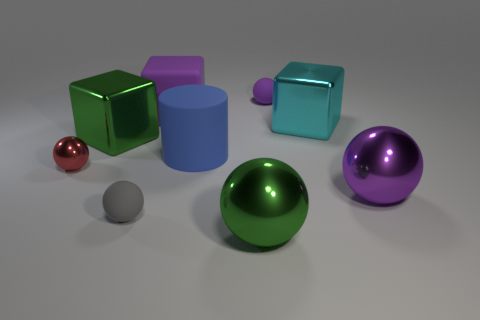How big is the object that is behind the blue object and to the right of the small purple rubber sphere?
Keep it short and to the point. Large. What color is the shiny object that is both in front of the big blue matte thing and left of the green metal sphere?
Keep it short and to the point. Red. Is there anything else that is made of the same material as the red ball?
Provide a short and direct response. Yes. Is the number of cyan shiny blocks that are in front of the small gray object less than the number of tiny purple matte spheres that are on the left side of the small red thing?
Your answer should be compact. No. Are there any other things that are the same color as the small metallic sphere?
Offer a very short reply. No. What is the shape of the red metal object?
Provide a succinct answer. Sphere. What is the color of the big thing that is made of the same material as the purple cube?
Provide a succinct answer. Blue. Is the number of tiny purple spheres greater than the number of tiny cyan metal spheres?
Ensure brevity in your answer.  Yes. Is there a purple rubber sphere?
Ensure brevity in your answer.  Yes. There is a tiny rubber thing in front of the green thing that is left of the small gray object; what shape is it?
Offer a terse response. Sphere. 